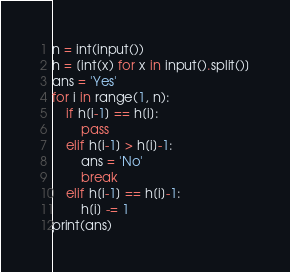Convert code to text. <code><loc_0><loc_0><loc_500><loc_500><_Python_>n = int(input())
h = [int(x) for x in input().split()]
ans = 'Yes'
for i in range(1, n):
    if h[i-1] == h[i]:
        pass
    elif h[i-1] > h[i]-1:
        ans = 'No'
        break
    elif h[i-1] == h[i]-1:
        h[i] -= 1
print(ans)</code> 